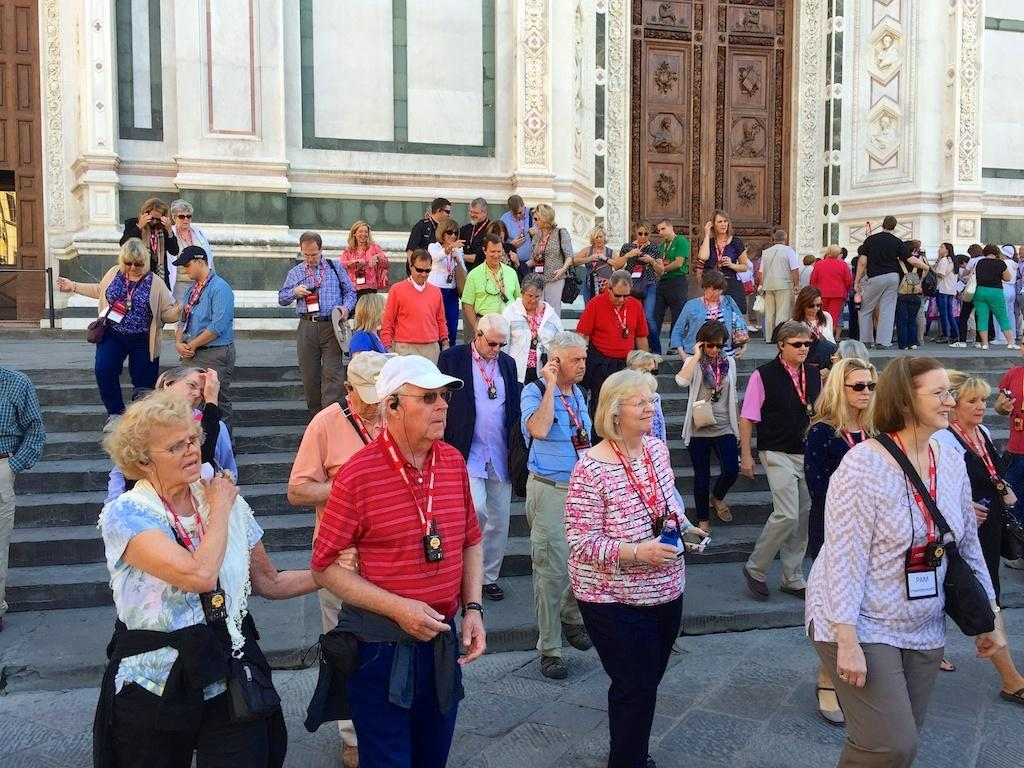What is happening in the image involving a group of people? There is a group of people in the image, and they are on the ground. Can you describe the attire of some people in the group? Some people in the group are wearing bags. What can be seen in the background of the image? There is a fence and a building in the background of the image. What is the income of the people in the image? There is no information about the income of the people in the image. --- Facts: 1. There is a car in the image. 2. The car is red. 3. The car has four wheels. 4. There is a road in the image. 5. The road is paved. Absurd Topics: dance, ocean, melody Conversation: What is the main subject of the image? The main subject of the image is a car. Can you describe the car's appearance? The car is red and has four wheels. What can be seen in the background of the image? There is a road in the image. How is the road constructed? The road is paved. Reasoning: Let's think step by step in order to produce the conversation. We start by identifying the main subject in the image, which is the car. Then, we expand the conversation to include details about the car's appearance, such as its color and the number of wheels. Finally, we describe the background of the image, which includes a road, and provide information about the road's construction. Absurd Question/Answer: What type of dance is being performed on the car in the image? There is no dance or dancing activity depicted in the image; it features a red car with four wheels on a paved road. 